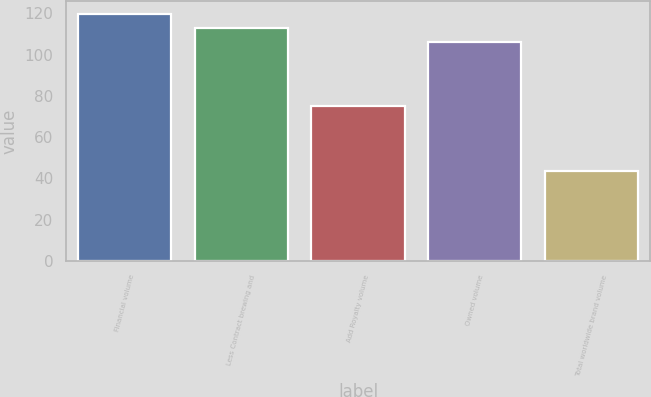<chart> <loc_0><loc_0><loc_500><loc_500><bar_chart><fcel>Financial volume<fcel>Less Contract brewing and<fcel>Add Royalty volume<fcel>Owned volume<fcel>Total worldwide brand volume<nl><fcel>119.86<fcel>112.98<fcel>75.3<fcel>106.1<fcel>43.4<nl></chart> 